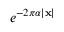Convert formula to latex. <formula><loc_0><loc_0><loc_500><loc_500>e ^ { - 2 \pi \alpha | x | }</formula> 